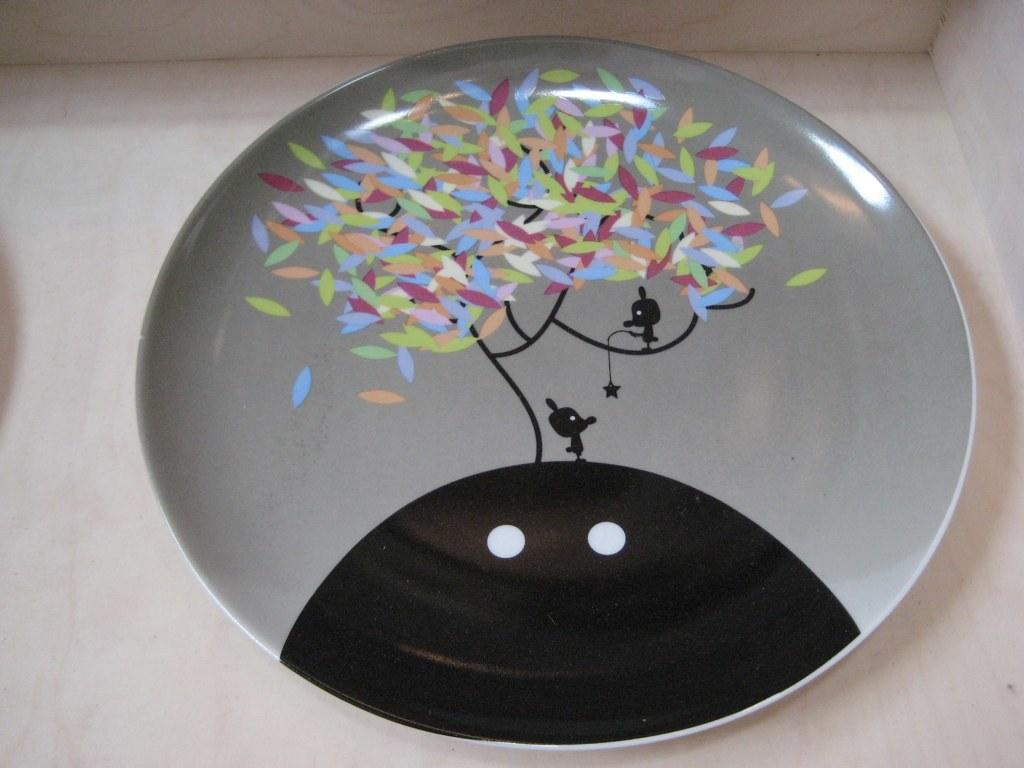What material is the object in the image made from? The object in the image is made from glass. What type of operation is being performed on the gold in the image? There is no gold or operation present in the image; it only features an object made from glass. How many chickens can be seen in the image? There are no chickens present in the image. 